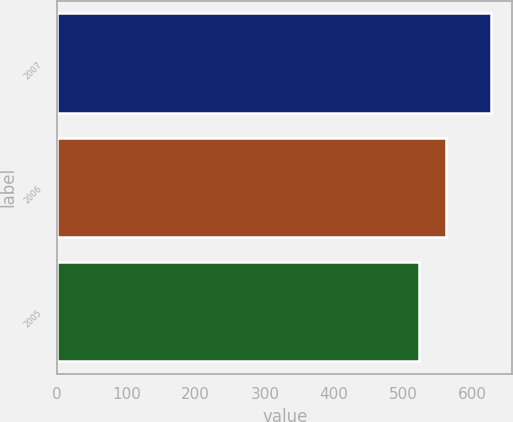Convert chart to OTSL. <chart><loc_0><loc_0><loc_500><loc_500><bar_chart><fcel>2007<fcel>2006<fcel>2005<nl><fcel>626<fcel>561<fcel>523<nl></chart> 